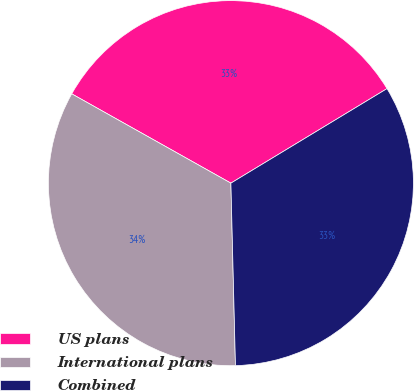Convert chart to OTSL. <chart><loc_0><loc_0><loc_500><loc_500><pie_chart><fcel>US plans<fcel>International plans<fcel>Combined<nl><fcel>33.2%<fcel>33.54%<fcel>33.27%<nl></chart> 